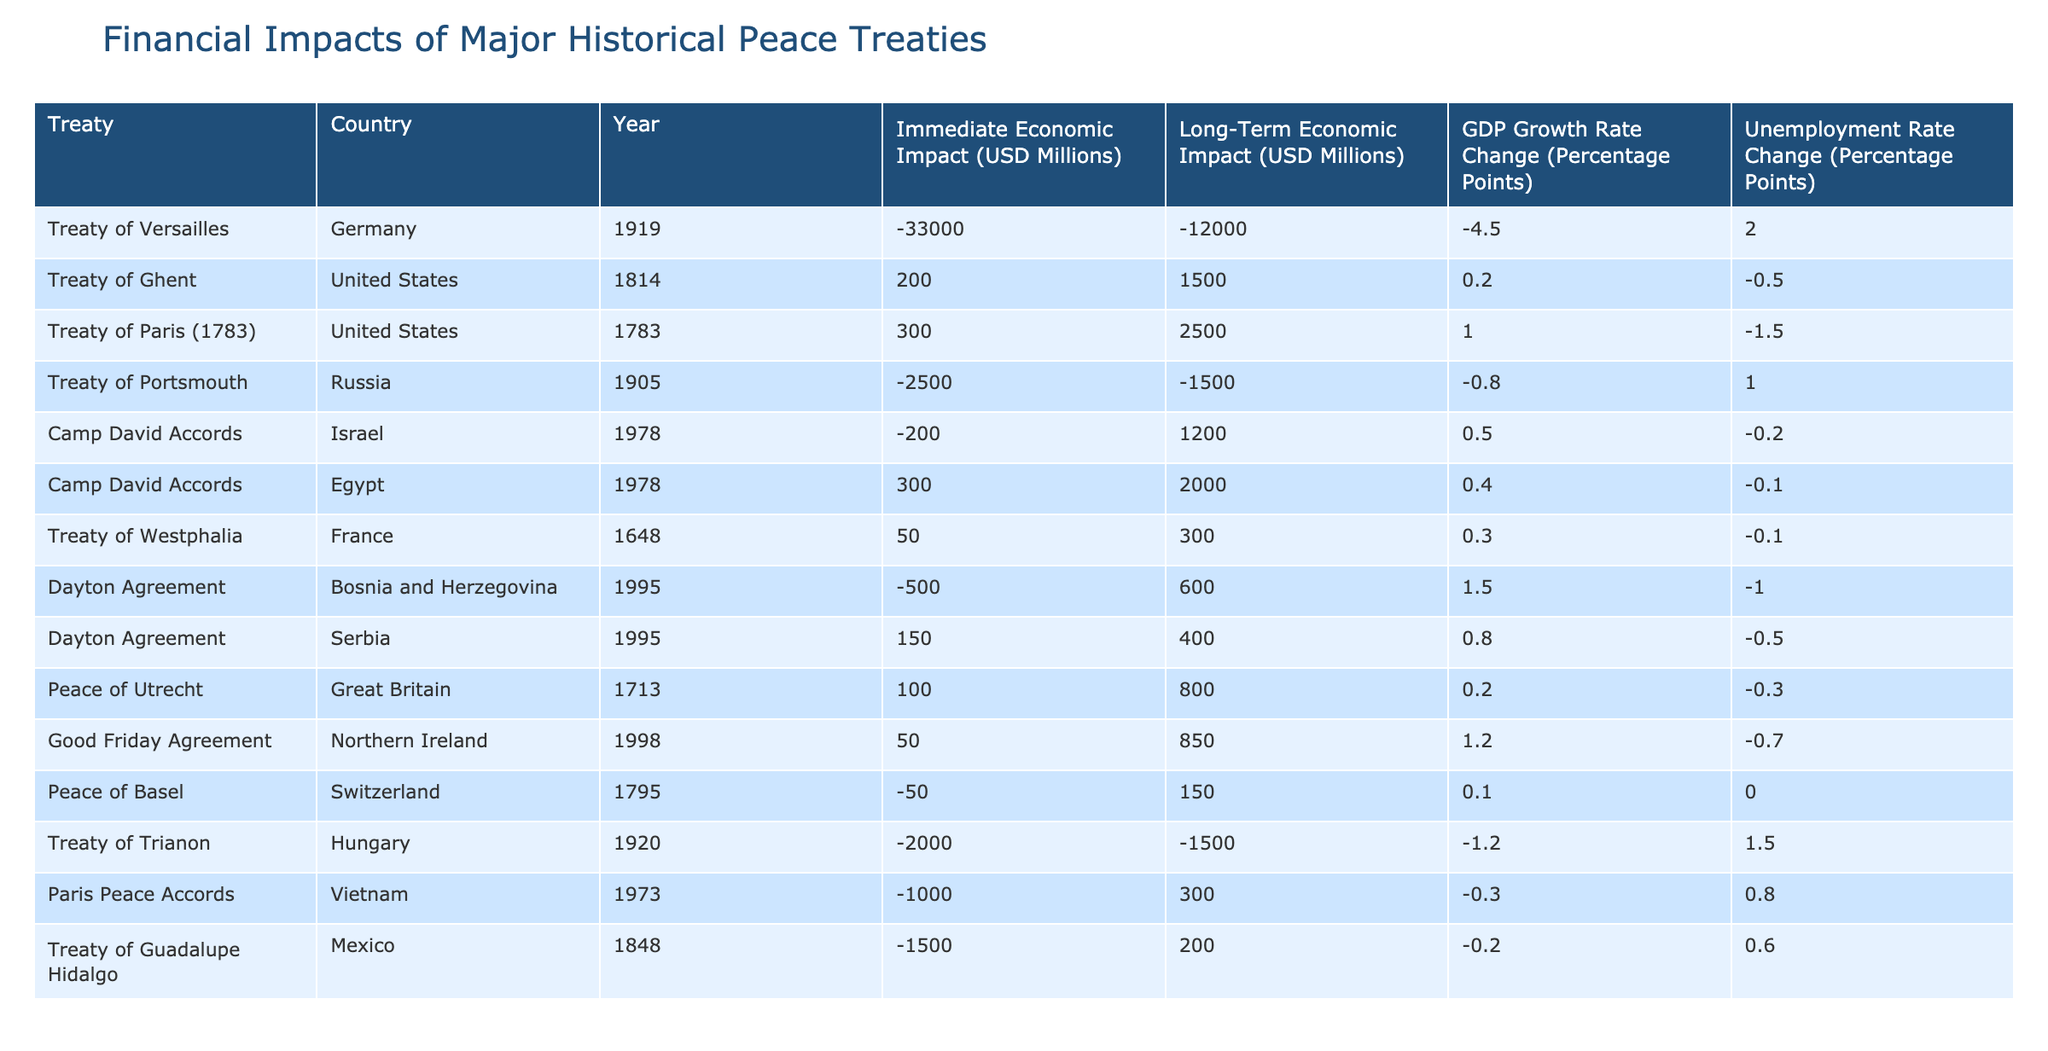What was the immediate economic impact of the Treaty of Versailles on Germany? According to the table, the immediate economic impact of the Treaty of Versailles on Germany was -33,000 USD millions. This value is stated directly in the row relating to the Treaty of Versailles for Germany.
Answer: -33,000 USD millions Which treaty had the highest long-term economic impact for the United States and what was it? Looking at the table, the Treaty of Paris (1783) shows a long-term economic impact of 2,500 USD millions, which is higher than the values for all other treaties impacting the United States. Therefore, it had the highest long-term economic impact for the U.S.
Answer: Treaty of Paris (1783), 2,500 USD millions Did the Camp David Accords have a positive immediate economic impact for any country? In reviewing the immediate economic impacts, the Camp David Accords had an immediate economic impact of 300 USD millions for Egypt, which is a positive value. Thus, the statement is true.
Answer: Yes What was the difference between the immediate economic impacts of the Treaty of Trianon and the Treaty of Versailles? From the table, the Treaty of Trianon had an immediate economic impact of -2,000 USD millions and the Treaty of Versailles had an impact of -33,000 USD millions. The difference is calculated as -2,000 - (-33,000) = 31,000 USD millions.
Answer: 31,000 USD millions Which treaty resulted in a decrease in unemployment for Serbia and what was the amount? According to the table, the Dayton Agreement for Serbia resulted in a decrease of 0.5 percentage points in the unemployment rate, which indicates a reduction. This specific detail can be found in the row for the Dayton Agreement related to Serbia.
Answer: Dayton Agreement, 0.5 percentage points What was the overall GDP growth rate change for both Egypt and Israel after the Camp David Accords? For Egypt, the GDP growth rate change was 0.4 percentage points, and for Israel, it was 0.5 percentage points. Adding these together gives 0.4 + 0.5 = 0.9 percentage points.
Answer: 0.9 percentage points How many treaties had a negative long-term economic impact on countries involved? After checking the table, we find that the treaties with a negative long-term economic impact are the Treaty of Versailles, Treaty of Portsmouth, Treaty of Trianon, and the Treaty of Guadalupe Hidalgo—four treaties in total.
Answer: Four treaties Was there a treaty that resulted in a decrease in GDP growth rate for Germany, and if so, what was the percentage point change? The Treaty of Versailles indeed resulted in a decrease in GDP growth rate for Germany, with a change of -4.5 percentage points specified in the table. Thus, the answer to the question is yes.
Answer: Yes, -4.5 percentage points 